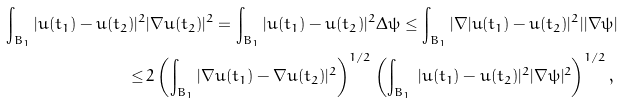<formula> <loc_0><loc_0><loc_500><loc_500>\int _ { B _ { 1 } } | u ( t _ { 1 } ) - u ( t _ { 2 } ) | ^ { 2 } & | \nabla u ( t _ { 2 } ) | ^ { 2 } = \int _ { B _ { 1 } } | u ( t _ { 1 } ) - u ( t _ { 2 } ) | ^ { 2 } \Delta \psi \leq \int _ { B _ { 1 } } | \nabla | u ( t _ { 1 } ) - u ( t _ { 2 } ) | ^ { 2 } | | \nabla \psi | \\ \leq \, & 2 \left ( \int _ { B _ { 1 } } | \nabla u ( t _ { 1 } ) - \nabla u ( t _ { 2 } ) | ^ { 2 } \right ) ^ { 1 / 2 } \left ( \int _ { B _ { 1 } } \, | u ( t _ { 1 } ) - u ( t _ { 2 } ) | ^ { 2 } | \nabla \psi | ^ { 2 } \right ) ^ { 1 / 2 } ,</formula> 